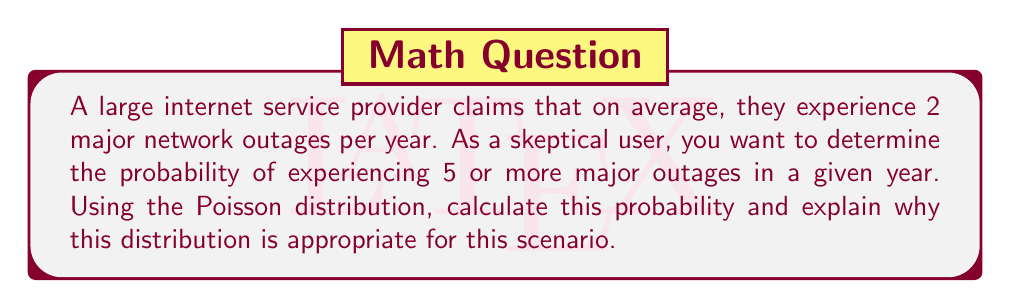Can you answer this question? Let's approach this step-by-step:

1) The Poisson distribution is appropriate for this scenario because:
   a) We're dealing with rare events (major network outages) in a large dataset (all network activity over a year).
   b) Events occur independently of each other.
   c) The average rate of occurrence is known and constant (λ = 2 per year).

2) The Poisson probability mass function is:

   $$ P(X = k) = \frac{e^{-\lambda} \lambda^k}{k!} $$

   Where λ is the average rate and k is the number of occurrences.

3) We need to find P(X ≥ 5), which is equivalent to 1 - P(X ≤ 4):

   $$ P(X \geq 5) = 1 - [P(X = 0) + P(X = 1) + P(X = 2) + P(X = 3) + P(X = 4)] $$

4) Let's calculate each probability:

   $P(X = 0) = \frac{e^{-2} 2^0}{0!} = e^{-2} \approx 0.1353$
   
   $P(X = 1) = \frac{e^{-2} 2^1}{1!} = 2e^{-2} \approx 0.2707$
   
   $P(X = 2) = \frac{e^{-2} 2^2}{2!} = 2e^{-2} \approx 0.2707$
   
   $P(X = 3) = \frac{e^{-2} 2^3}{3!} = \frac{4}{3}e^{-2} \approx 0.1804$
   
   $P(X = 4) = \frac{e^{-2} 2^4}{4!} = \frac{2}{3}e^{-2} \approx 0.0902$

5) Sum these probabilities and subtract from 1:

   $P(X \geq 5) = 1 - (0.1353 + 0.2707 + 0.2707 + 0.1804 + 0.0902)$
                $= 1 - 0.9473$
                $= 0.0527$

Therefore, the probability of experiencing 5 or more major outages in a year is approximately 0.0527 or 5.27%.
Answer: 0.0527 or 5.27% 